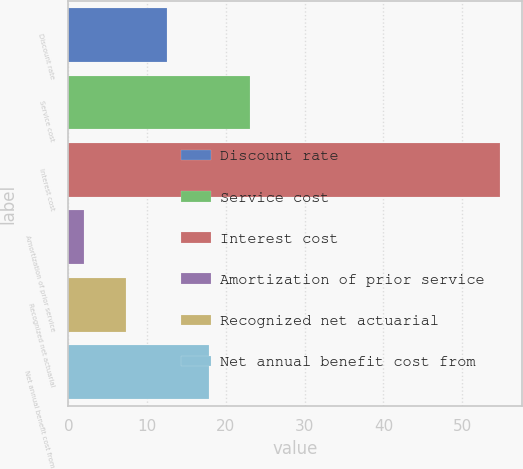<chart> <loc_0><loc_0><loc_500><loc_500><bar_chart><fcel>Discount rate<fcel>Service cost<fcel>Interest cost<fcel>Amortization of prior service<fcel>Recognized net actuarial<fcel>Net annual benefit cost from<nl><fcel>12.56<fcel>23.12<fcel>54.8<fcel>2<fcel>7.28<fcel>17.84<nl></chart> 